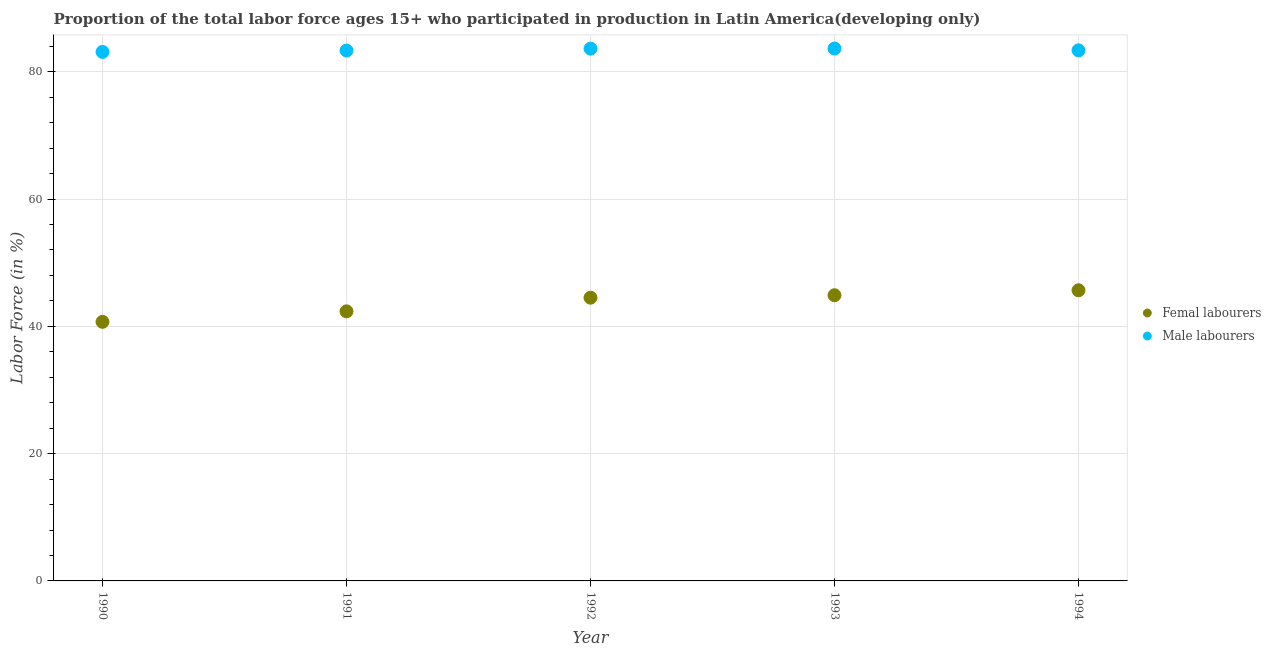Is the number of dotlines equal to the number of legend labels?
Your answer should be very brief. Yes. What is the percentage of male labour force in 1992?
Your response must be concise. 83.63. Across all years, what is the maximum percentage of female labor force?
Keep it short and to the point. 45.67. Across all years, what is the minimum percentage of male labour force?
Give a very brief answer. 83.11. In which year was the percentage of male labour force minimum?
Provide a short and direct response. 1990. What is the total percentage of male labour force in the graph?
Your response must be concise. 417.08. What is the difference between the percentage of male labour force in 1991 and that in 1992?
Give a very brief answer. -0.3. What is the difference between the percentage of male labour force in 1994 and the percentage of female labor force in 1991?
Offer a terse response. 41.01. What is the average percentage of female labor force per year?
Give a very brief answer. 43.62. In the year 1993, what is the difference between the percentage of male labour force and percentage of female labor force?
Provide a succinct answer. 38.76. In how many years, is the percentage of female labor force greater than 44 %?
Keep it short and to the point. 3. What is the ratio of the percentage of male labour force in 1992 to that in 1994?
Make the answer very short. 1. Is the percentage of male labour force in 1991 less than that in 1993?
Your answer should be very brief. Yes. What is the difference between the highest and the second highest percentage of female labor force?
Make the answer very short. 0.78. What is the difference between the highest and the lowest percentage of female labor force?
Your response must be concise. 4.96. In how many years, is the percentage of male labour force greater than the average percentage of male labour force taken over all years?
Make the answer very short. 2. Is the percentage of female labor force strictly less than the percentage of male labour force over the years?
Give a very brief answer. Yes. How many dotlines are there?
Your answer should be very brief. 2. How many years are there in the graph?
Your answer should be compact. 5. What is the difference between two consecutive major ticks on the Y-axis?
Your response must be concise. 20. Are the values on the major ticks of Y-axis written in scientific E-notation?
Keep it short and to the point. No. Does the graph contain grids?
Make the answer very short. Yes. How many legend labels are there?
Your answer should be very brief. 2. How are the legend labels stacked?
Keep it short and to the point. Vertical. What is the title of the graph?
Your answer should be very brief. Proportion of the total labor force ages 15+ who participated in production in Latin America(developing only). Does "Working capital" appear as one of the legend labels in the graph?
Your response must be concise. No. What is the label or title of the X-axis?
Your answer should be very brief. Year. What is the label or title of the Y-axis?
Provide a succinct answer. Labor Force (in %). What is the Labor Force (in %) of Femal labourers in 1990?
Provide a short and direct response. 40.71. What is the Labor Force (in %) in Male labourers in 1990?
Keep it short and to the point. 83.11. What is the Labor Force (in %) in Femal labourers in 1991?
Your answer should be compact. 42.35. What is the Labor Force (in %) of Male labourers in 1991?
Make the answer very short. 83.33. What is the Labor Force (in %) in Femal labourers in 1992?
Offer a terse response. 44.5. What is the Labor Force (in %) in Male labourers in 1992?
Make the answer very short. 83.63. What is the Labor Force (in %) in Femal labourers in 1993?
Make the answer very short. 44.88. What is the Labor Force (in %) in Male labourers in 1993?
Ensure brevity in your answer.  83.64. What is the Labor Force (in %) of Femal labourers in 1994?
Offer a very short reply. 45.67. What is the Labor Force (in %) of Male labourers in 1994?
Your answer should be compact. 83.36. Across all years, what is the maximum Labor Force (in %) in Femal labourers?
Offer a terse response. 45.67. Across all years, what is the maximum Labor Force (in %) in Male labourers?
Keep it short and to the point. 83.64. Across all years, what is the minimum Labor Force (in %) of Femal labourers?
Provide a short and direct response. 40.71. Across all years, what is the minimum Labor Force (in %) of Male labourers?
Provide a short and direct response. 83.11. What is the total Labor Force (in %) of Femal labourers in the graph?
Offer a terse response. 218.11. What is the total Labor Force (in %) of Male labourers in the graph?
Keep it short and to the point. 417.08. What is the difference between the Labor Force (in %) of Femal labourers in 1990 and that in 1991?
Give a very brief answer. -1.65. What is the difference between the Labor Force (in %) in Male labourers in 1990 and that in 1991?
Offer a very short reply. -0.22. What is the difference between the Labor Force (in %) in Femal labourers in 1990 and that in 1992?
Your response must be concise. -3.79. What is the difference between the Labor Force (in %) of Male labourers in 1990 and that in 1992?
Make the answer very short. -0.51. What is the difference between the Labor Force (in %) of Femal labourers in 1990 and that in 1993?
Your response must be concise. -4.18. What is the difference between the Labor Force (in %) of Male labourers in 1990 and that in 1993?
Your answer should be very brief. -0.53. What is the difference between the Labor Force (in %) in Femal labourers in 1990 and that in 1994?
Your answer should be very brief. -4.96. What is the difference between the Labor Force (in %) of Femal labourers in 1991 and that in 1992?
Offer a very short reply. -2.14. What is the difference between the Labor Force (in %) of Male labourers in 1991 and that in 1992?
Keep it short and to the point. -0.3. What is the difference between the Labor Force (in %) of Femal labourers in 1991 and that in 1993?
Provide a succinct answer. -2.53. What is the difference between the Labor Force (in %) in Male labourers in 1991 and that in 1993?
Make the answer very short. -0.32. What is the difference between the Labor Force (in %) of Femal labourers in 1991 and that in 1994?
Your response must be concise. -3.31. What is the difference between the Labor Force (in %) in Male labourers in 1991 and that in 1994?
Offer a terse response. -0.03. What is the difference between the Labor Force (in %) of Femal labourers in 1992 and that in 1993?
Provide a short and direct response. -0.39. What is the difference between the Labor Force (in %) in Male labourers in 1992 and that in 1993?
Ensure brevity in your answer.  -0.02. What is the difference between the Labor Force (in %) of Femal labourers in 1992 and that in 1994?
Your response must be concise. -1.17. What is the difference between the Labor Force (in %) in Male labourers in 1992 and that in 1994?
Your answer should be compact. 0.26. What is the difference between the Labor Force (in %) in Femal labourers in 1993 and that in 1994?
Offer a terse response. -0.78. What is the difference between the Labor Force (in %) of Male labourers in 1993 and that in 1994?
Your answer should be very brief. 0.28. What is the difference between the Labor Force (in %) of Femal labourers in 1990 and the Labor Force (in %) of Male labourers in 1991?
Your response must be concise. -42.62. What is the difference between the Labor Force (in %) in Femal labourers in 1990 and the Labor Force (in %) in Male labourers in 1992?
Make the answer very short. -42.92. What is the difference between the Labor Force (in %) in Femal labourers in 1990 and the Labor Force (in %) in Male labourers in 1993?
Make the answer very short. -42.94. What is the difference between the Labor Force (in %) in Femal labourers in 1990 and the Labor Force (in %) in Male labourers in 1994?
Your answer should be very brief. -42.66. What is the difference between the Labor Force (in %) of Femal labourers in 1991 and the Labor Force (in %) of Male labourers in 1992?
Provide a short and direct response. -41.27. What is the difference between the Labor Force (in %) of Femal labourers in 1991 and the Labor Force (in %) of Male labourers in 1993?
Keep it short and to the point. -41.29. What is the difference between the Labor Force (in %) in Femal labourers in 1991 and the Labor Force (in %) in Male labourers in 1994?
Offer a terse response. -41.01. What is the difference between the Labor Force (in %) of Femal labourers in 1992 and the Labor Force (in %) of Male labourers in 1993?
Provide a succinct answer. -39.15. What is the difference between the Labor Force (in %) of Femal labourers in 1992 and the Labor Force (in %) of Male labourers in 1994?
Offer a terse response. -38.86. What is the difference between the Labor Force (in %) of Femal labourers in 1993 and the Labor Force (in %) of Male labourers in 1994?
Make the answer very short. -38.48. What is the average Labor Force (in %) of Femal labourers per year?
Offer a terse response. 43.62. What is the average Labor Force (in %) in Male labourers per year?
Keep it short and to the point. 83.42. In the year 1990, what is the difference between the Labor Force (in %) of Femal labourers and Labor Force (in %) of Male labourers?
Provide a short and direct response. -42.41. In the year 1991, what is the difference between the Labor Force (in %) in Femal labourers and Labor Force (in %) in Male labourers?
Keep it short and to the point. -40.97. In the year 1992, what is the difference between the Labor Force (in %) in Femal labourers and Labor Force (in %) in Male labourers?
Make the answer very short. -39.13. In the year 1993, what is the difference between the Labor Force (in %) of Femal labourers and Labor Force (in %) of Male labourers?
Your answer should be very brief. -38.76. In the year 1994, what is the difference between the Labor Force (in %) of Femal labourers and Labor Force (in %) of Male labourers?
Your response must be concise. -37.7. What is the ratio of the Labor Force (in %) in Femal labourers in 1990 to that in 1991?
Make the answer very short. 0.96. What is the ratio of the Labor Force (in %) of Male labourers in 1990 to that in 1991?
Your response must be concise. 1. What is the ratio of the Labor Force (in %) in Femal labourers in 1990 to that in 1992?
Make the answer very short. 0.91. What is the ratio of the Labor Force (in %) of Male labourers in 1990 to that in 1992?
Make the answer very short. 0.99. What is the ratio of the Labor Force (in %) in Femal labourers in 1990 to that in 1993?
Your answer should be compact. 0.91. What is the ratio of the Labor Force (in %) in Femal labourers in 1990 to that in 1994?
Offer a terse response. 0.89. What is the ratio of the Labor Force (in %) of Male labourers in 1990 to that in 1994?
Give a very brief answer. 1. What is the ratio of the Labor Force (in %) in Femal labourers in 1991 to that in 1992?
Make the answer very short. 0.95. What is the ratio of the Labor Force (in %) of Male labourers in 1991 to that in 1992?
Your answer should be very brief. 1. What is the ratio of the Labor Force (in %) of Femal labourers in 1991 to that in 1993?
Make the answer very short. 0.94. What is the ratio of the Labor Force (in %) of Femal labourers in 1991 to that in 1994?
Offer a very short reply. 0.93. What is the ratio of the Labor Force (in %) in Male labourers in 1991 to that in 1994?
Provide a succinct answer. 1. What is the ratio of the Labor Force (in %) in Male labourers in 1992 to that in 1993?
Offer a very short reply. 1. What is the ratio of the Labor Force (in %) in Femal labourers in 1992 to that in 1994?
Make the answer very short. 0.97. What is the ratio of the Labor Force (in %) of Femal labourers in 1993 to that in 1994?
Offer a very short reply. 0.98. What is the difference between the highest and the second highest Labor Force (in %) of Femal labourers?
Provide a short and direct response. 0.78. What is the difference between the highest and the second highest Labor Force (in %) of Male labourers?
Provide a short and direct response. 0.02. What is the difference between the highest and the lowest Labor Force (in %) in Femal labourers?
Offer a very short reply. 4.96. What is the difference between the highest and the lowest Labor Force (in %) of Male labourers?
Provide a succinct answer. 0.53. 